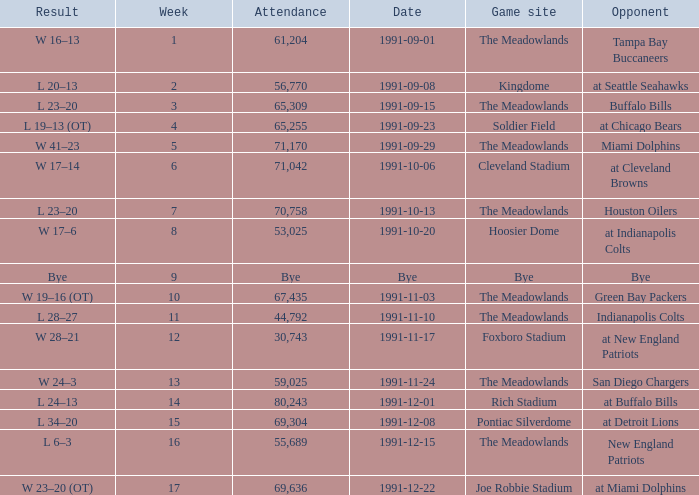What was the Result of the Game at the Meadowlands on 1991-09-01? W 16–13. 